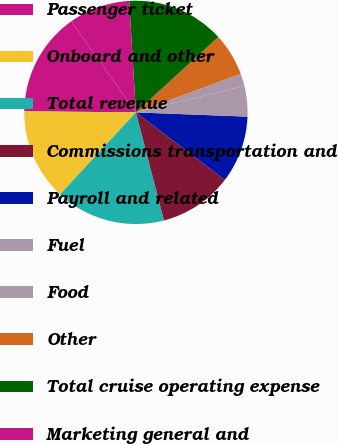Convert chart to OTSL. <chart><loc_0><loc_0><loc_500><loc_500><pie_chart><fcel>Passenger ticket<fcel>Onboard and other<fcel>Total revenue<fcel>Commissions transportation and<fcel>Payroll and related<fcel>Fuel<fcel>Food<fcel>Other<fcel>Total cruise operating expense<fcel>Marketing general and<nl><fcel>15.04%<fcel>13.27%<fcel>15.92%<fcel>10.62%<fcel>9.73%<fcel>4.43%<fcel>1.78%<fcel>6.2%<fcel>14.16%<fcel>8.85%<nl></chart> 